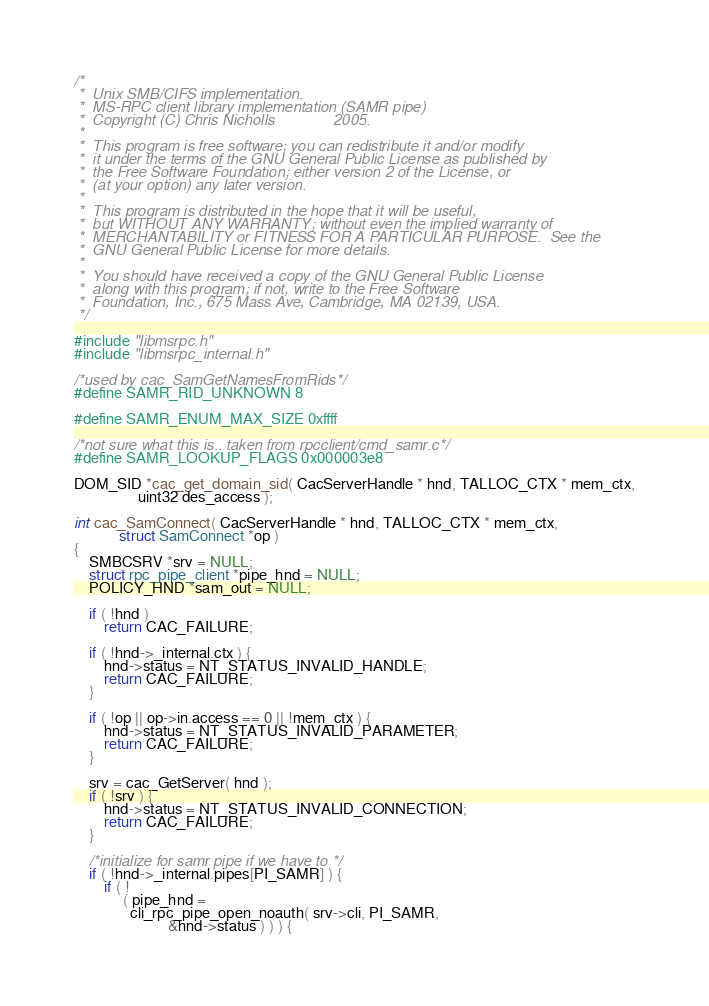<code> <loc_0><loc_0><loc_500><loc_500><_C_>
/* 
 *  Unix SMB/CIFS implementation.
 *  MS-RPC client library implementation (SAMR pipe)
 *  Copyright (C) Chris Nicholls              2005.
 *  
 *  This program is free software; you can redistribute it and/or modify
 *  it under the terms of the GNU General Public License as published by
 *  the Free Software Foundation; either version 2 of the License, or
 *  (at your option) any later version.
 *  
 *  This program is distributed in the hope that it will be useful,
 *  but WITHOUT ANY WARRANTY; without even the implied warranty of
 *  MERCHANTABILITY or FITNESS FOR A PARTICULAR PURPOSE.  See the
 *  GNU General Public License for more details.
 *  
 *  You should have received a copy of the GNU General Public License
 *  along with this program; if not, write to the Free Software
 *  Foundation, Inc., 675 Mass Ave, Cambridge, MA 02139, USA.
 */

#include "libmsrpc.h"
#include "libmsrpc_internal.h"

/*used by cac_SamGetNamesFromRids*/
#define SAMR_RID_UNKNOWN 8

#define SAMR_ENUM_MAX_SIZE 0xffff

/*not sure what this is.. taken from rpcclient/cmd_samr.c*/
#define SAMR_LOOKUP_FLAGS 0x000003e8

DOM_SID *cac_get_domain_sid( CacServerHandle * hnd, TALLOC_CTX * mem_ctx,
			     uint32 des_access );

int cac_SamConnect( CacServerHandle * hnd, TALLOC_CTX * mem_ctx,
		    struct SamConnect *op )
{
	SMBCSRV *srv = NULL;
	struct rpc_pipe_client *pipe_hnd = NULL;
	POLICY_HND *sam_out = NULL;

	if ( !hnd )
		return CAC_FAILURE;

	if ( !hnd->_internal.ctx ) {
		hnd->status = NT_STATUS_INVALID_HANDLE;
		return CAC_FAILURE;
	}

	if ( !op || op->in.access == 0 || !mem_ctx ) {
		hnd->status = NT_STATUS_INVALID_PARAMETER;
		return CAC_FAILURE;
	}

	srv = cac_GetServer( hnd );
	if ( !srv ) {
		hnd->status = NT_STATUS_INVALID_CONNECTION;
		return CAC_FAILURE;
	}

	/*initialize for samr pipe if we have to */
	if ( !hnd->_internal.pipes[PI_SAMR] ) {
		if ( !
		     ( pipe_hnd =
		       cli_rpc_pipe_open_noauth( srv->cli, PI_SAMR,
						 &hnd->status ) ) ) {</code> 